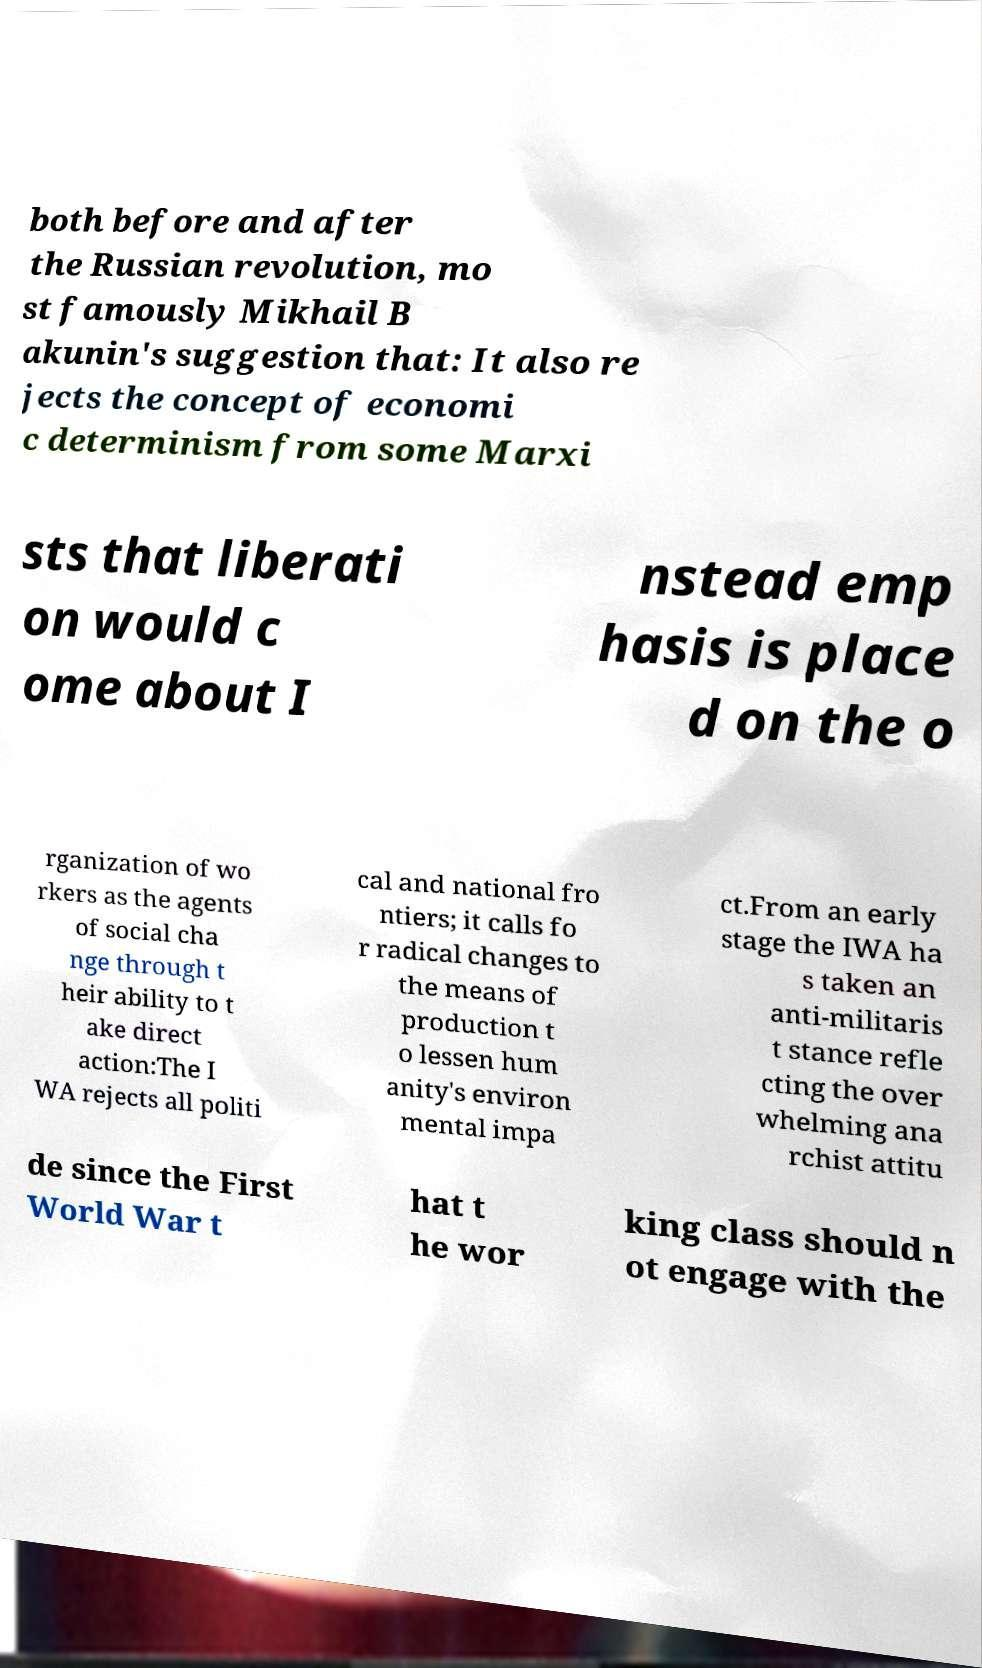For documentation purposes, I need the text within this image transcribed. Could you provide that? both before and after the Russian revolution, mo st famously Mikhail B akunin's suggestion that: It also re jects the concept of economi c determinism from some Marxi sts that liberati on would c ome about I nstead emp hasis is place d on the o rganization of wo rkers as the agents of social cha nge through t heir ability to t ake direct action:The I WA rejects all politi cal and national fro ntiers; it calls fo r radical changes to the means of production t o lessen hum anity's environ mental impa ct.From an early stage the IWA ha s taken an anti-militaris t stance refle cting the over whelming ana rchist attitu de since the First World War t hat t he wor king class should n ot engage with the 